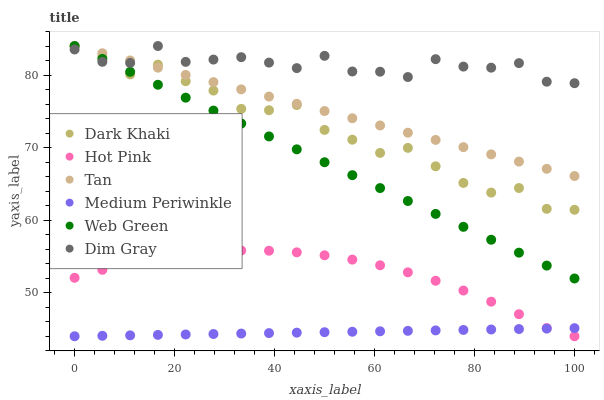Does Medium Periwinkle have the minimum area under the curve?
Answer yes or no. Yes. Does Dim Gray have the maximum area under the curve?
Answer yes or no. Yes. Does Hot Pink have the minimum area under the curve?
Answer yes or no. No. Does Hot Pink have the maximum area under the curve?
Answer yes or no. No. Is Medium Periwinkle the smoothest?
Answer yes or no. Yes. Is Dark Khaki the roughest?
Answer yes or no. Yes. Is Hot Pink the smoothest?
Answer yes or no. No. Is Hot Pink the roughest?
Answer yes or no. No. Does Hot Pink have the lowest value?
Answer yes or no. Yes. Does Web Green have the lowest value?
Answer yes or no. No. Does Tan have the highest value?
Answer yes or no. Yes. Does Hot Pink have the highest value?
Answer yes or no. No. Is Hot Pink less than Dim Gray?
Answer yes or no. Yes. Is Dim Gray greater than Hot Pink?
Answer yes or no. Yes. Does Dark Khaki intersect Dim Gray?
Answer yes or no. Yes. Is Dark Khaki less than Dim Gray?
Answer yes or no. No. Is Dark Khaki greater than Dim Gray?
Answer yes or no. No. Does Hot Pink intersect Dim Gray?
Answer yes or no. No. 